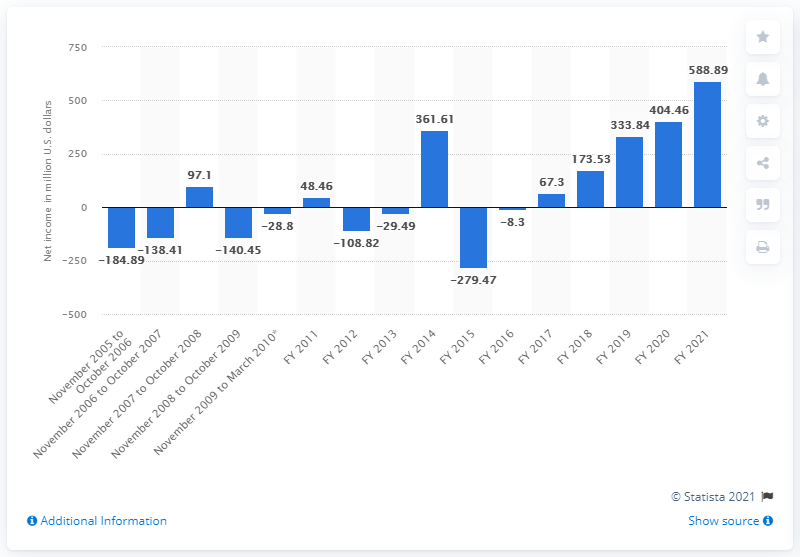Draw attention to some important aspects in this diagram. Take-Two Interactive's net income in 2021 was $588.89 million. 